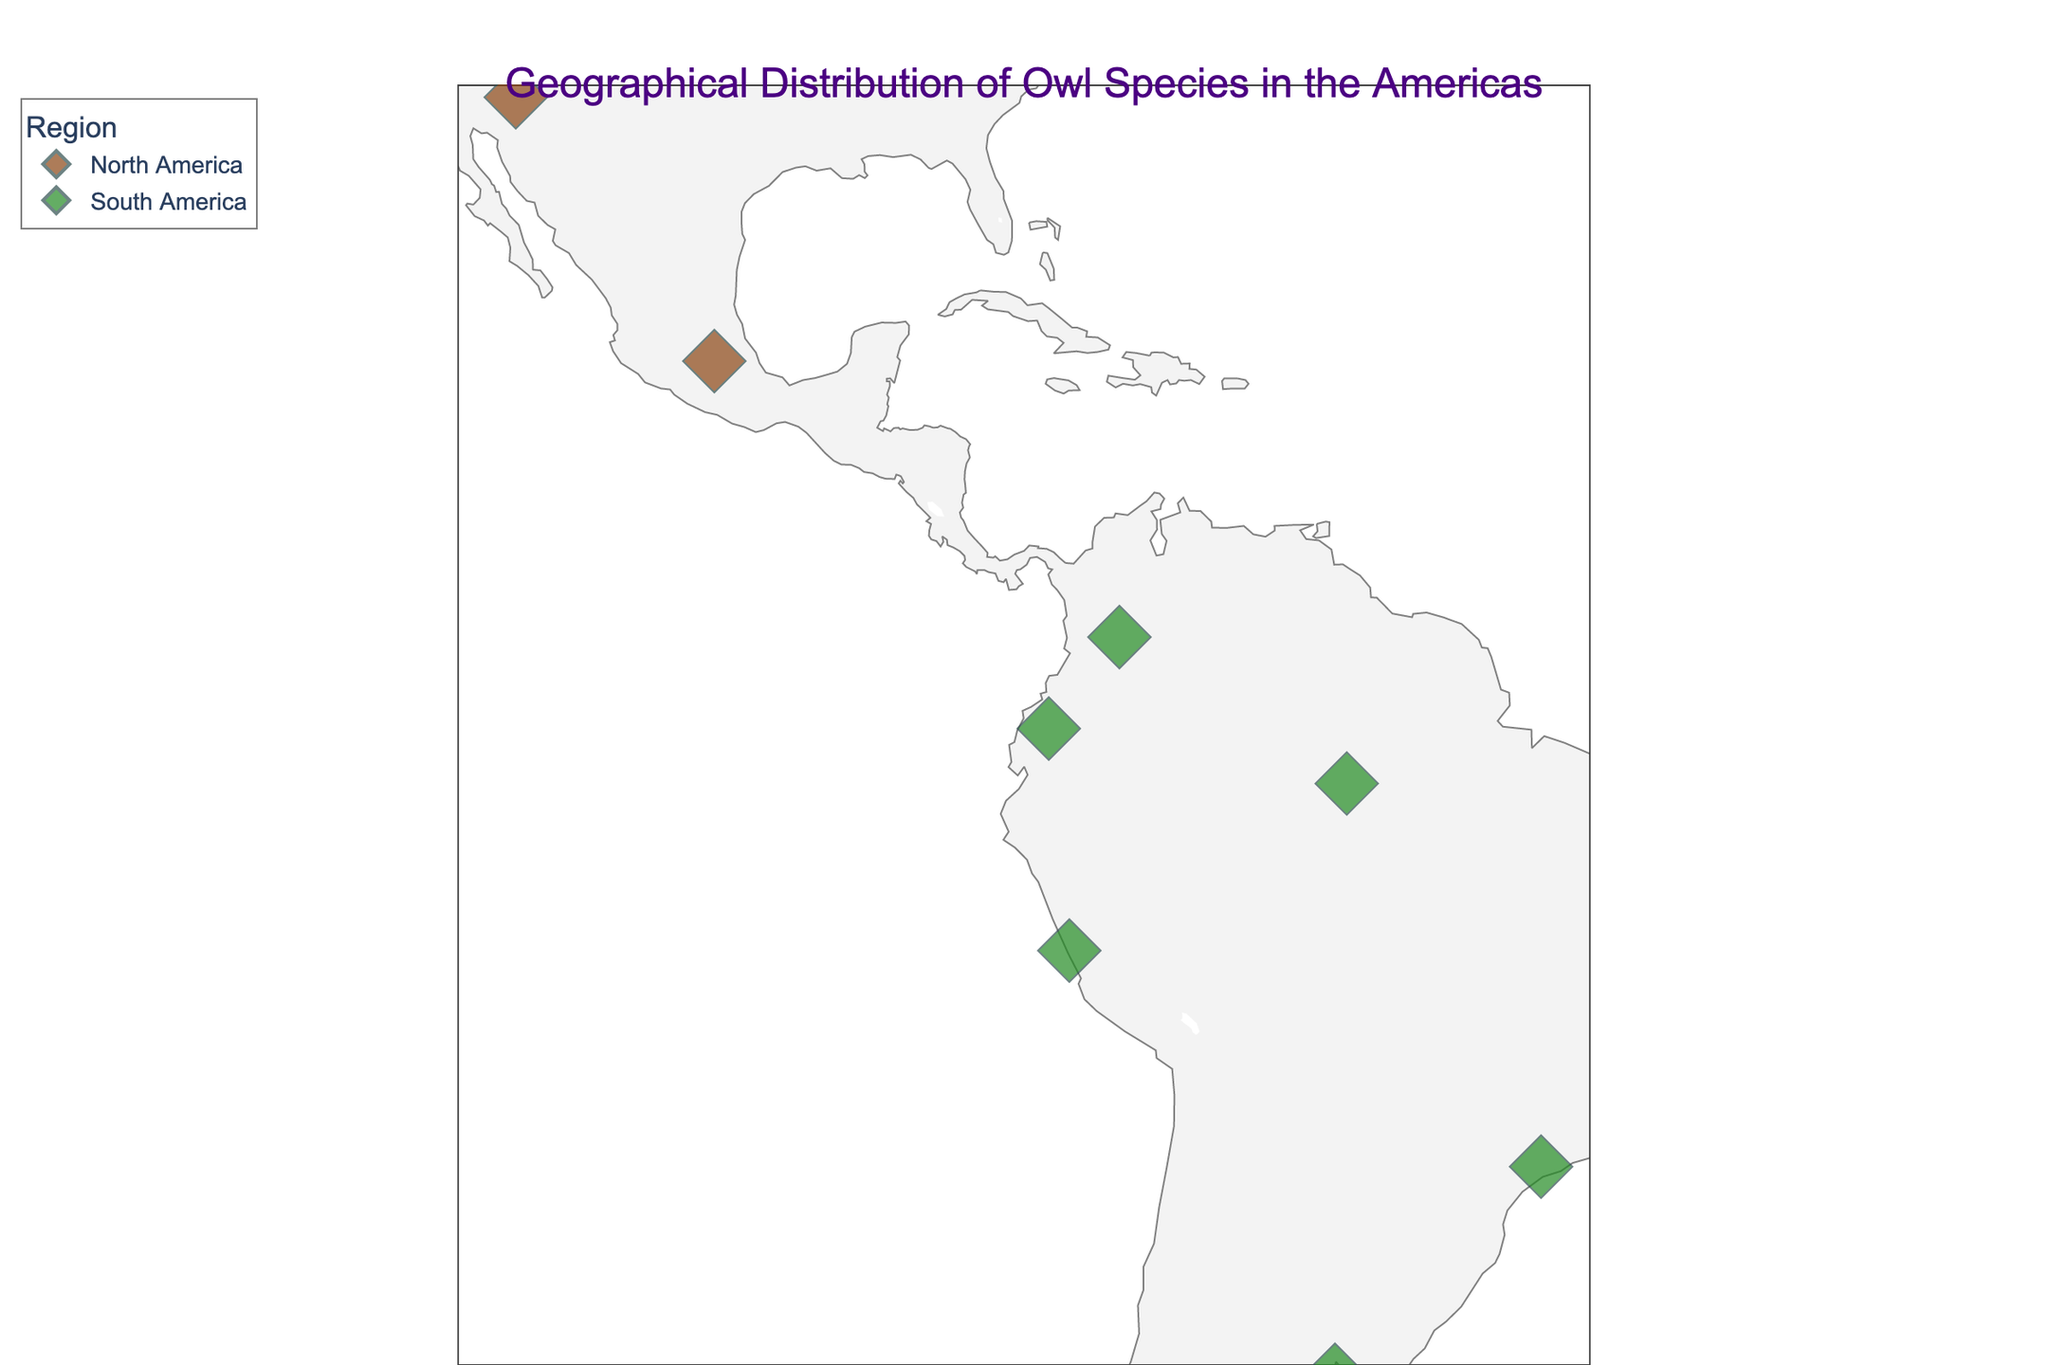Which regions are represented in the plot? The plot shows two distinct regions: North America and South America, as indicated by the color legend.
Answer: North America, South America How many species of owls are plotted from each region? There are five species in North America and six species in South America, as indicated by the number of data points and their hover labels.
Answer: North America: 5, South America: 6 What is the most northern owl species shown on the plot? By examining the latitudes, the Barred Owl, located at latitude 47.6062, is the most northern species.
Answer: Barred Owl Which species is closest to the equator? The Crested Owl, located at latitude -0.1807, is the closest to the equator, as it has the smallest absolute value of latitude.
Answer: Crested Owl Which species are plotted at the closest longitudes in North America? The Spotted Owl at longitude -122.4194 and the Barred Owl at longitude -122.3321 are closest in longitude values within North America.
Answer: Spotted Owl, Barred Owl Compare the latitudes of the Spotted Owl and the Tropical Screech-Owl. Which is further south? The Tropical Screech-Owl, with a latitude of -12.0464, is further south compared to the Spotted Owl with a latitude of 37.7749.
Answer: Tropical Screech-Owl What is the latitude range covered by the owl species in South America? The owl species in South America range from latitude 4.7110 (Spectacled Owl) to -34.6037 (Striped Owl), giving a range of 39.3147.
Answer: 39.3147 degrees Which species is located in Mexico? The Barn Owl, located at latitude 19.4326 and longitude -99.1332, is the only species located in Mexico.
Answer: Barn Owl What is the average latitude of the species in North America? Adding the latitudes of North American species (40.7128, 47.6062, 37.7749, 33.4484, 19.4326) and dividing by 5 gives an average latitude of approximately 35.79.
Answer: 35.79 degrees lat 